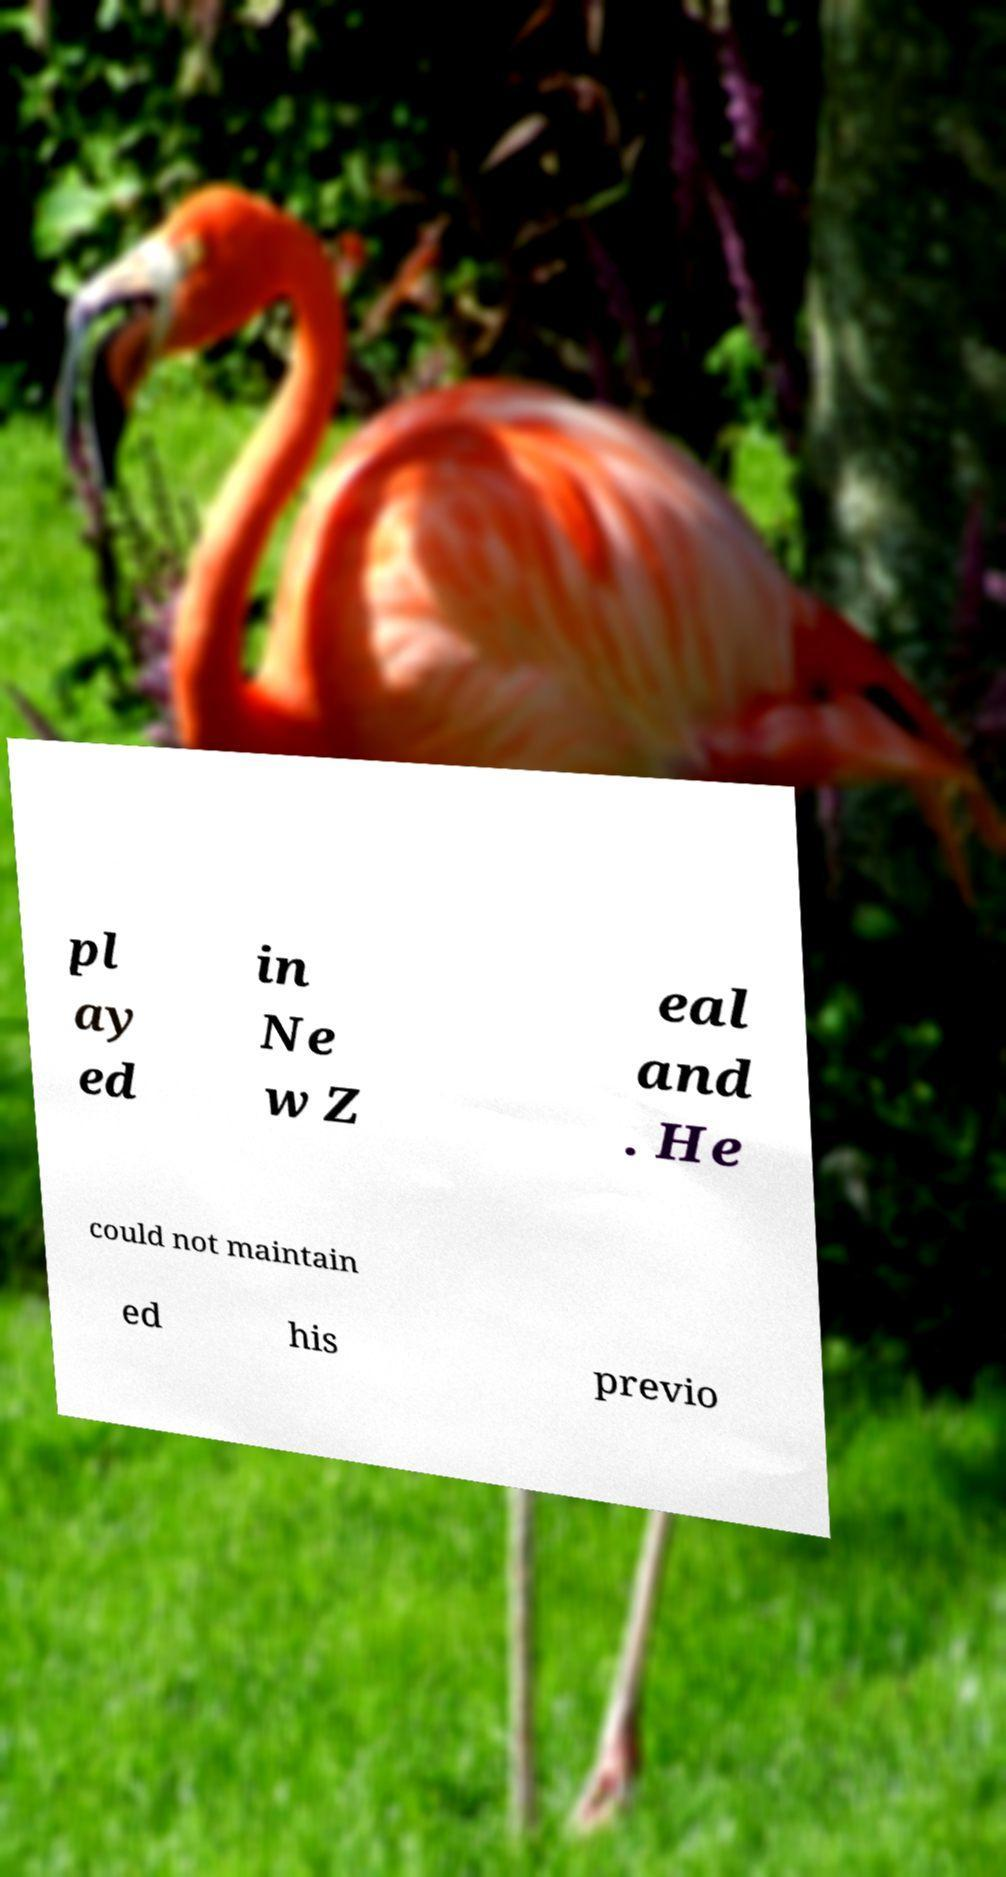Could you extract and type out the text from this image? pl ay ed in Ne w Z eal and . He could not maintain ed his previo 